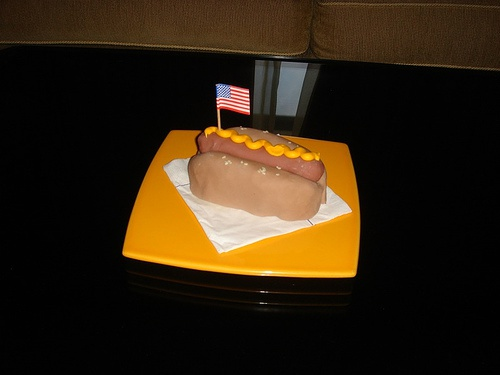Describe the objects in this image and their specific colors. I can see dining table in black, orange, tan, and red tones and hot dog in black, tan, salmon, and brown tones in this image. 